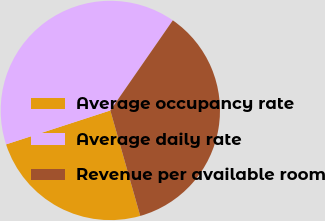<chart> <loc_0><loc_0><loc_500><loc_500><pie_chart><fcel>Average occupancy rate<fcel>Average daily rate<fcel>Revenue per available room<nl><fcel>24.39%<fcel>39.66%<fcel>35.95%<nl></chart> 